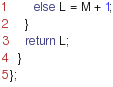<code> <loc_0><loc_0><loc_500><loc_500><_C++_>      else L = M + 1;
    }
    return L;
  }
};</code> 